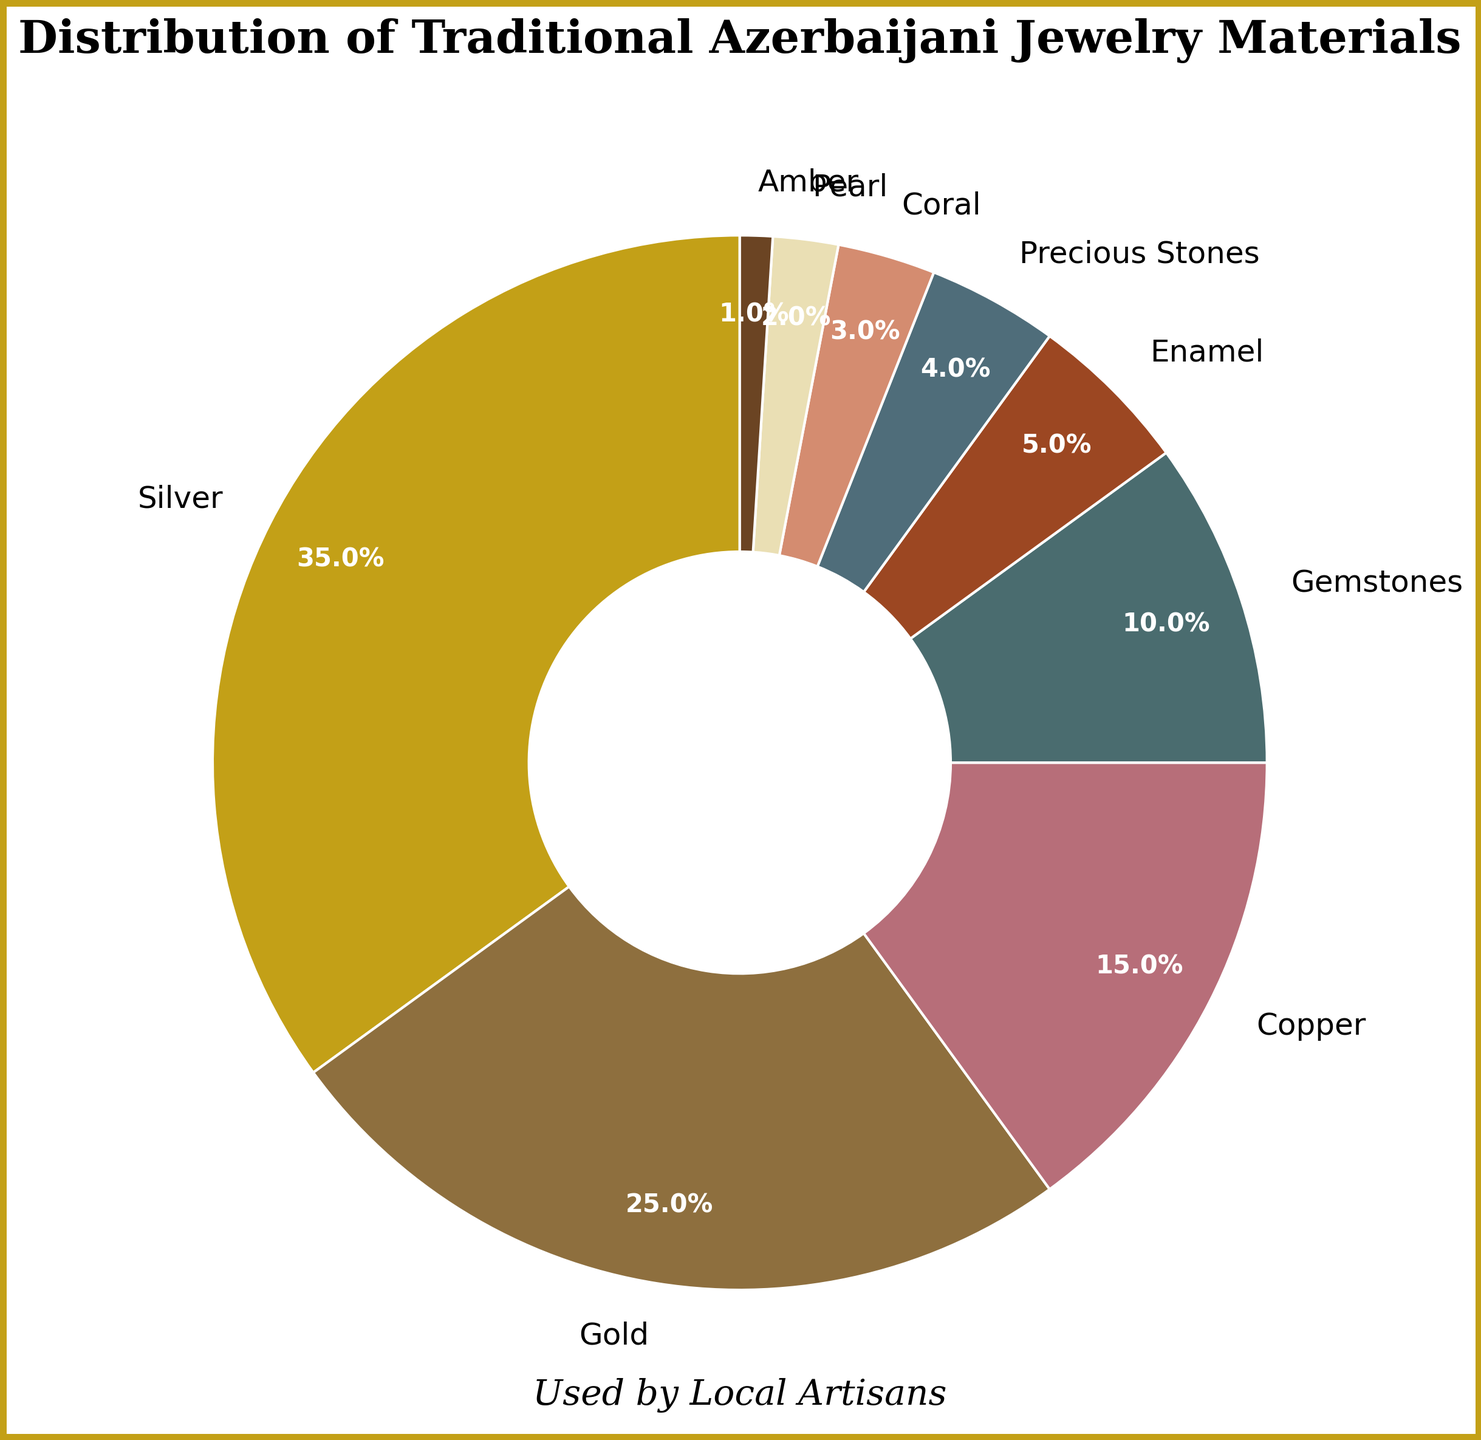What is the material with the highest percentage in the distribution? The material with the highest percentage can be identified by looking for the largest section of the pie chart. Silver occupies the largest segment.
Answer: Silver Which materials together make up more than half of the distribution? To determine the materials that together make up more than half, start by summing the percentages sequentially until the total exceeds 50%. Silver (35%), Gold (25%) together already sum up to 60%.
Answer: Silver and Gold How much more is the percentage of Silver compared to Copper? The percentage of Silver is 35%, and the percentage of Copper is 15%. Subtracting Copper's percentage from Silver's percentage gives 35% - 15% = 20%.
Answer: 20% If you combine the percentages of Gemstones, Enamel, Precious Stones, Coral, Pearl, and Amber, what is the total percentage? Summing the percentages of Gemstones (10%), Enamel (5%), Precious Stones (4%), Coral (3%), Pearl (2%), and Amber (1%) gives 10% + 5% + 4% + 3% + 2% + 1% = 25%.
Answer: 25% What is the difference in percentage between the material with the third highest and the material with the fifth highest representation? The material with the third highest percentage is Copper (15%) and the material with the fifth highest percentage is Enamel (5%). The difference is 15% - 5% = 10%.
Answer: 10% If you group materials with less than 5% into one category, what would be this new category's total percentage? Materials with less than 5% are Precious Stones (4%), Coral (3%), Pearl (2%), and Amber (1%). Summing these gives 4% + 3% + 2% + 1% = 10%.
Answer: 10% Which materials have a combined percentage equal to or greater than the percentage of Gold? Gold has a percentage of 25%. To find materials with a combined percentage equal to or greater than this, sum pairs or groups. Silver alone is 35%, and Copper (15%) + Gemstones (10%) also sums to 25%.
Answer: Silver / Copper and Gemstones How many materials have a percentage greater than 10%? Materials with a percentage greater than 10% are those visible with a larger segment than Gemstones (10%). These materials are Silver (35%), Gold (25%), and Copper (15%). Therefore, there are three materials.
Answer: 3 What are the two smallest categories in the distribution? The smallest segments in the pie chart will correspond to the smallest percentages. Amber (1%) and Pearl (2%) are the two smallest categories.
Answer: Amber and Pearl Can you identify a material whose percentage is equal to the sum of two other materials' percentages? Gemstones (10%) is equal to the sum of Enamel (5%) and Precious Stones (4%) + Coral (3%).
Answer: Gemstones = Enamel + Precious Stones + Coral 